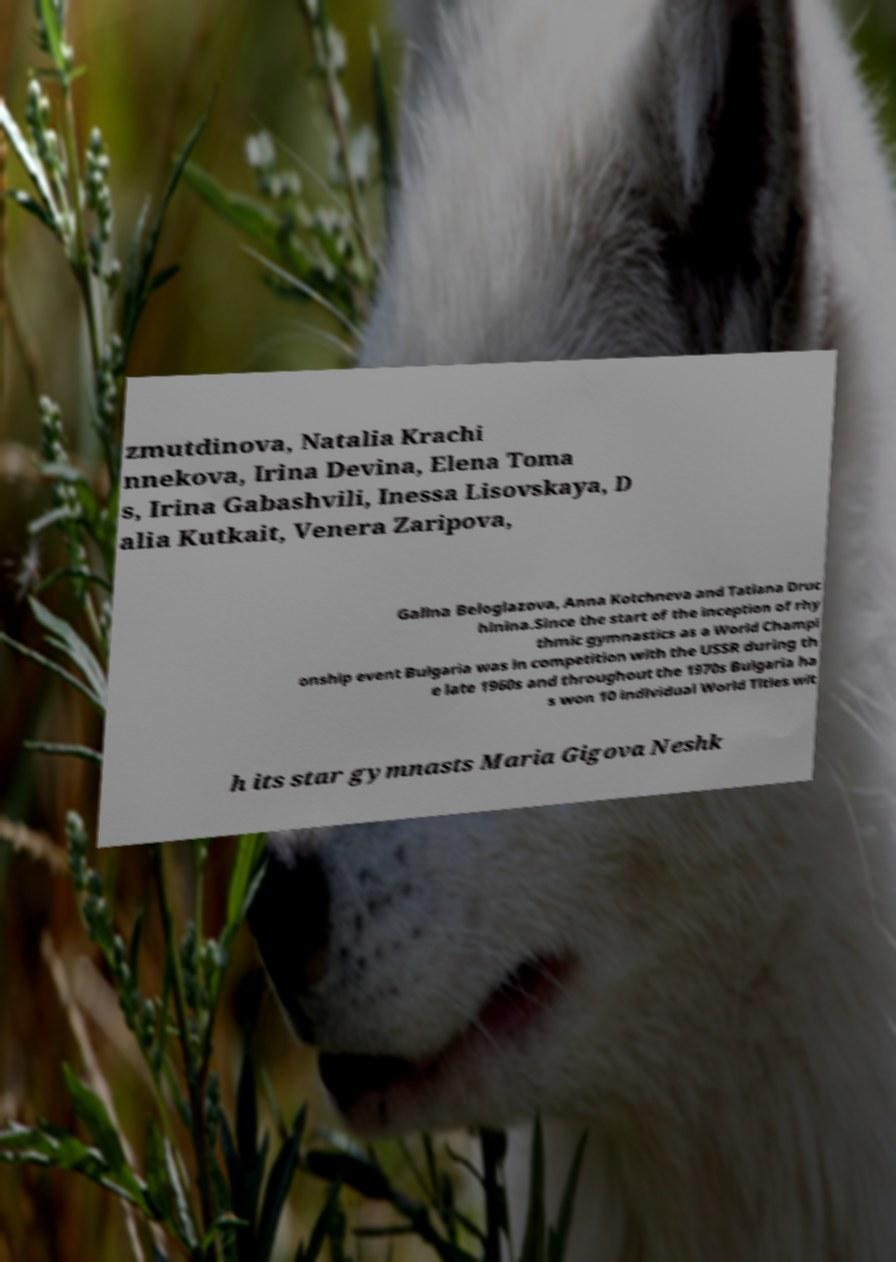Could you extract and type out the text from this image? zmutdinova, Natalia Krachi nnekova, Irina Devina, Elena Toma s, Irina Gabashvili, Inessa Lisovskaya, D alia Kutkait, Venera Zaripova, Galina Beloglazova, Anna Kotchneva and Tatiana Druc hinina.Since the start of the inception of rhy thmic gymnastics as a World Champi onship event Bulgaria was in competition with the USSR during th e late 1960s and throughout the 1970s Bulgaria ha s won 10 individual World Titles wit h its star gymnasts Maria Gigova Neshk 